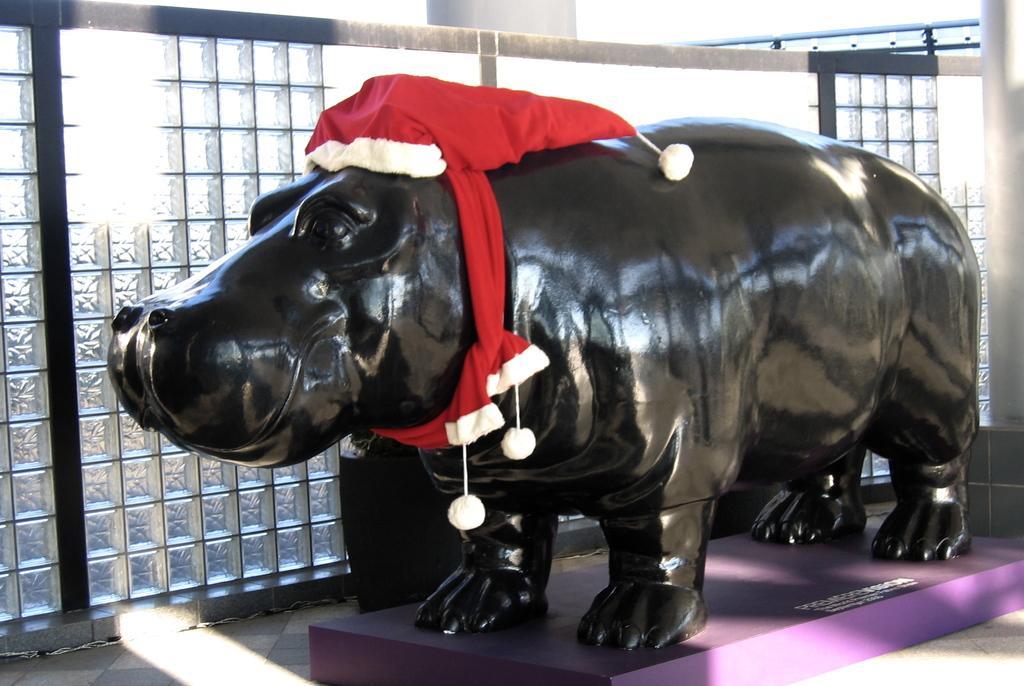Please provide a concise description of this image. In this picture we can observe a statue of a hippopotamus which is in black color. This statue was placed on the purple color surface. We can observe red color cap on the statue. In the background there is a wall. 